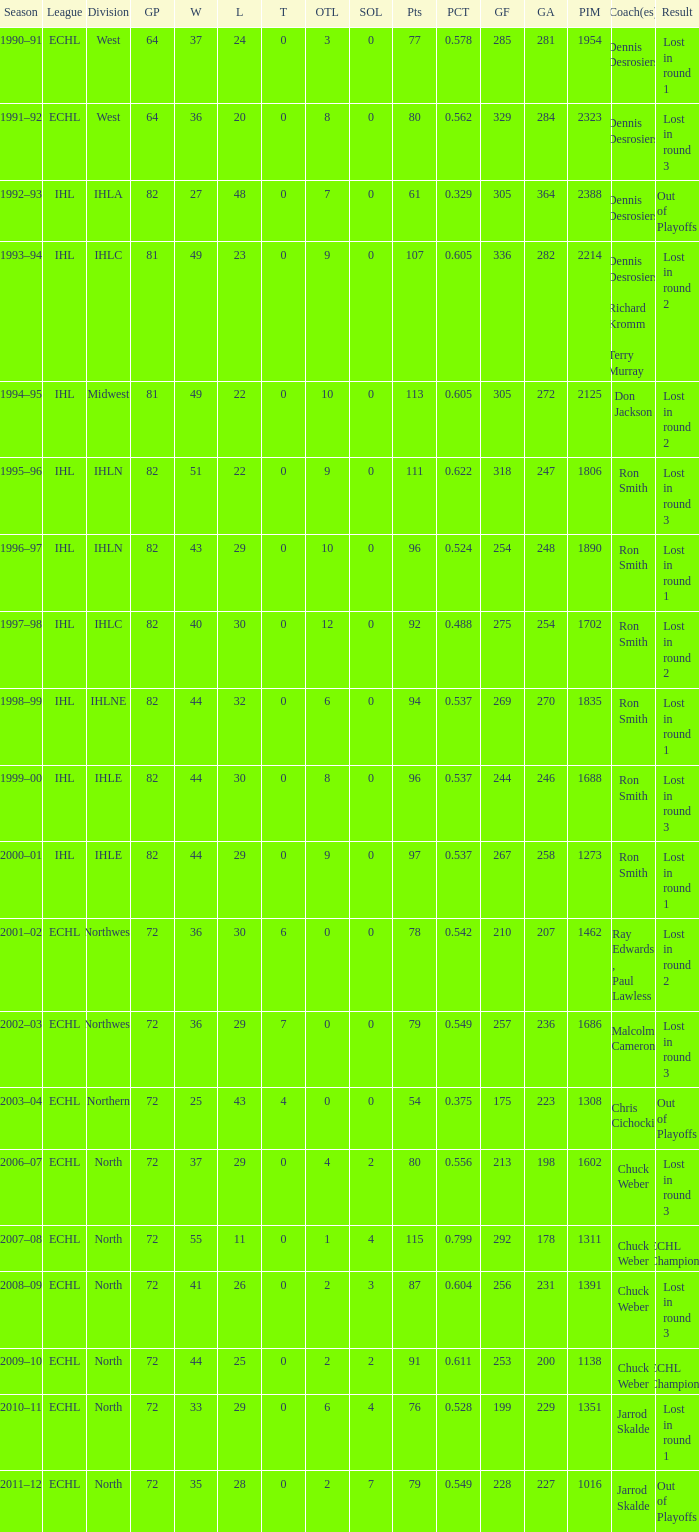When the team had a gp of 64, how many seasons did they experience a loss in round 1? 1.0. 